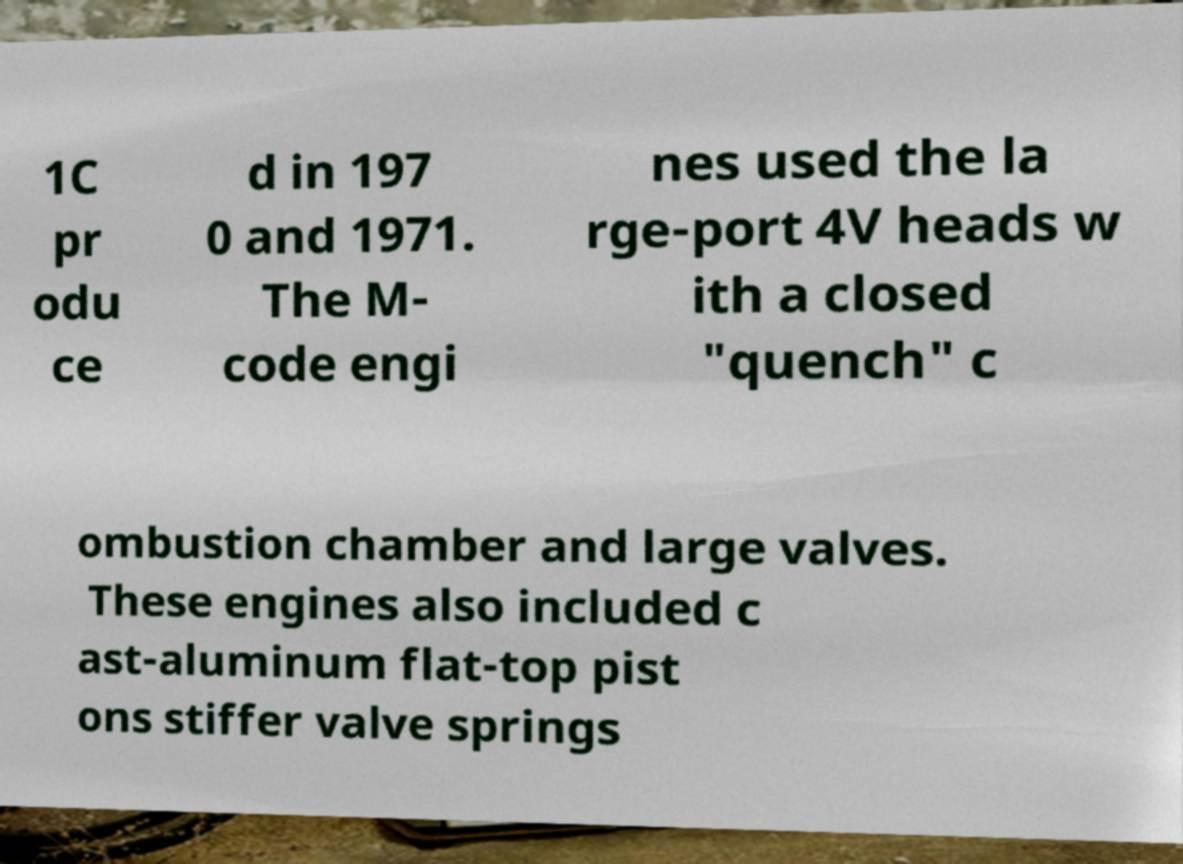There's text embedded in this image that I need extracted. Can you transcribe it verbatim? 1C pr odu ce d in 197 0 and 1971. The M- code engi nes used the la rge-port 4V heads w ith a closed "quench" c ombustion chamber and large valves. These engines also included c ast-aluminum flat-top pist ons stiffer valve springs 